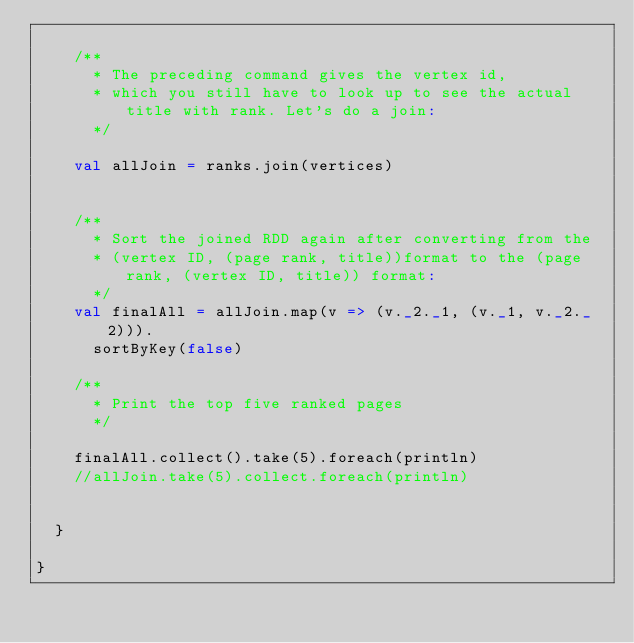<code> <loc_0><loc_0><loc_500><loc_500><_Scala_>
    /**
      * The preceding command gives the vertex id,
      * which you still have to look up to see the actual title with rank. Let's do a join:
      */

    val allJoin = ranks.join(vertices)


    /**
      * Sort the joined RDD again after converting from the
      * (vertex ID, (page rank, title))format to the (page rank, (vertex ID, title)) format:
      */
    val finalAll = allJoin.map(v => (v._2._1, (v._1, v._2._2))).
      sortByKey(false)

    /**
      * Print the top five ranked pages
      */

    finalAll.collect().take(5).foreach(println)
    //allJoin.take(5).collect.foreach(println)


  }

}
</code> 